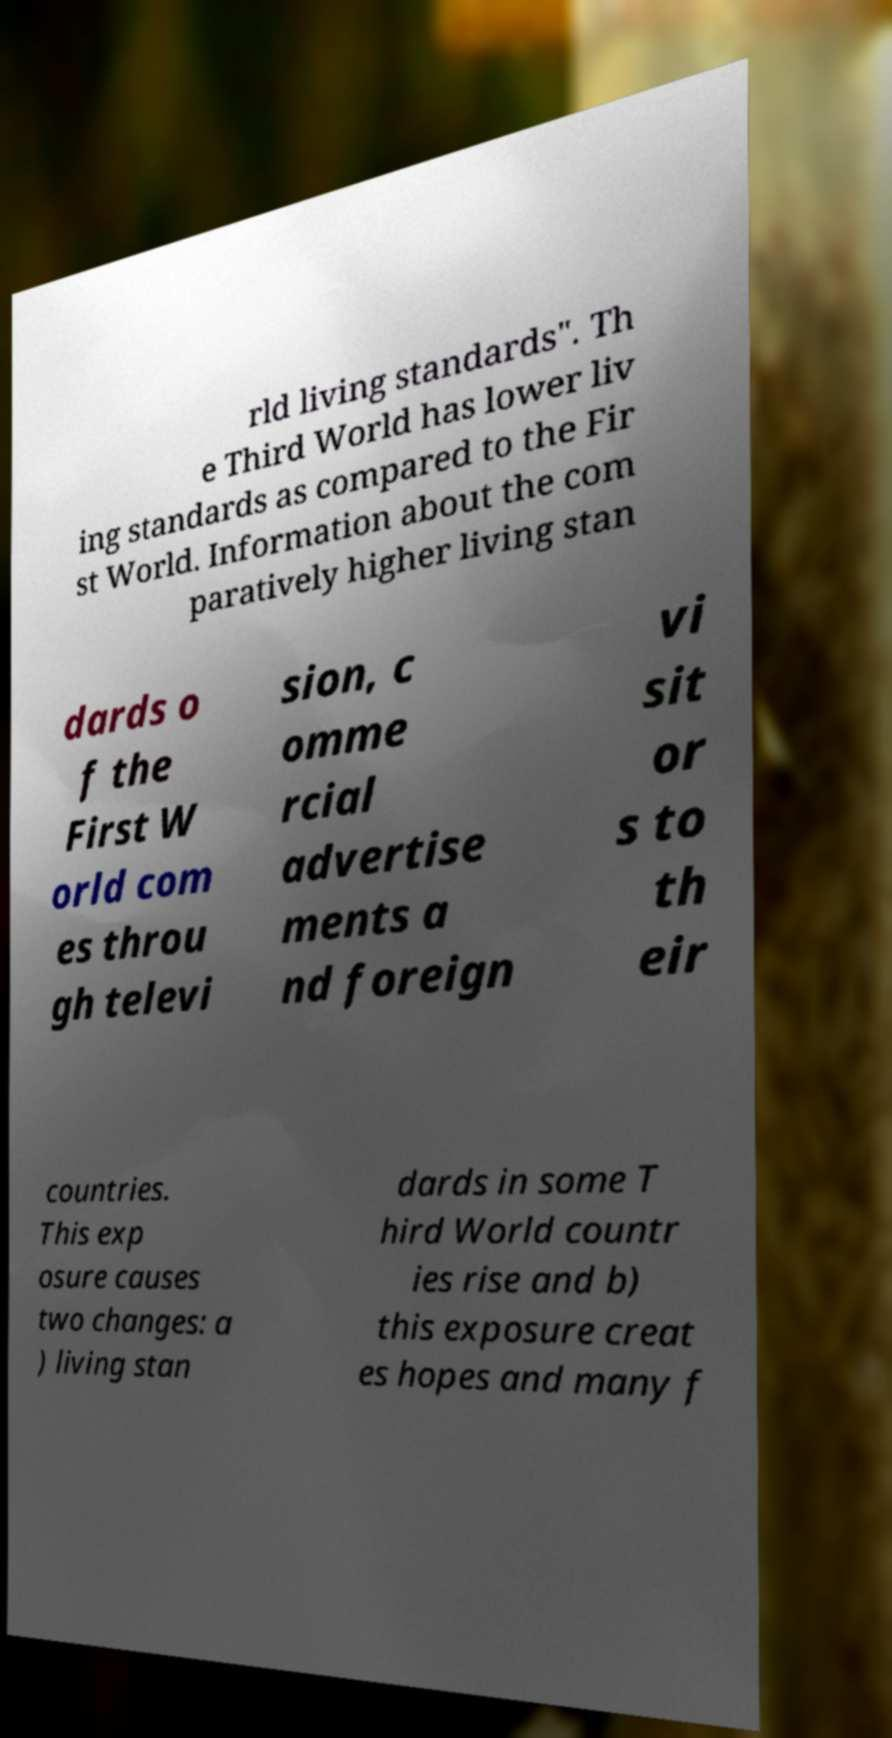Can you read and provide the text displayed in the image?This photo seems to have some interesting text. Can you extract and type it out for me? rld living standards". Th e Third World has lower liv ing standards as compared to the Fir st World. Information about the com paratively higher living stan dards o f the First W orld com es throu gh televi sion, c omme rcial advertise ments a nd foreign vi sit or s to th eir countries. This exp osure causes two changes: a ) living stan dards in some T hird World countr ies rise and b) this exposure creat es hopes and many f 